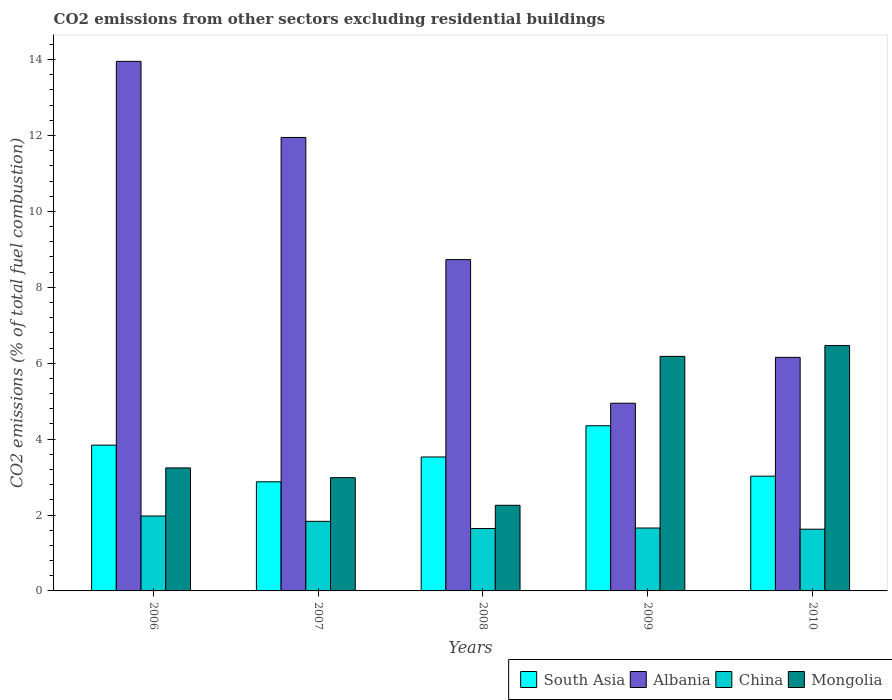How many different coloured bars are there?
Your answer should be very brief. 4. How many groups of bars are there?
Keep it short and to the point. 5. Are the number of bars per tick equal to the number of legend labels?
Ensure brevity in your answer.  Yes. How many bars are there on the 4th tick from the left?
Offer a very short reply. 4. What is the label of the 5th group of bars from the left?
Offer a terse response. 2010. In how many cases, is the number of bars for a given year not equal to the number of legend labels?
Offer a terse response. 0. What is the total CO2 emitted in Mongolia in 2007?
Give a very brief answer. 2.98. Across all years, what is the maximum total CO2 emitted in Albania?
Your answer should be compact. 13.95. Across all years, what is the minimum total CO2 emitted in China?
Your answer should be compact. 1.63. In which year was the total CO2 emitted in Albania maximum?
Provide a short and direct response. 2006. What is the total total CO2 emitted in Albania in the graph?
Provide a succinct answer. 45.73. What is the difference between the total CO2 emitted in South Asia in 2007 and that in 2010?
Your answer should be compact. -0.15. What is the difference between the total CO2 emitted in China in 2007 and the total CO2 emitted in Mongolia in 2010?
Provide a succinct answer. -4.63. What is the average total CO2 emitted in Mongolia per year?
Give a very brief answer. 4.23. In the year 2007, what is the difference between the total CO2 emitted in Albania and total CO2 emitted in South Asia?
Your answer should be compact. 9.07. What is the ratio of the total CO2 emitted in Mongolia in 2007 to that in 2009?
Offer a terse response. 0.48. Is the total CO2 emitted in Mongolia in 2008 less than that in 2009?
Offer a terse response. Yes. What is the difference between the highest and the second highest total CO2 emitted in South Asia?
Provide a succinct answer. 0.51. What is the difference between the highest and the lowest total CO2 emitted in South Asia?
Ensure brevity in your answer.  1.48. Is it the case that in every year, the sum of the total CO2 emitted in China and total CO2 emitted in Mongolia is greater than the sum of total CO2 emitted in Albania and total CO2 emitted in South Asia?
Keep it short and to the point. No. What does the 4th bar from the left in 2006 represents?
Your response must be concise. Mongolia. Are all the bars in the graph horizontal?
Ensure brevity in your answer.  No. How many years are there in the graph?
Your answer should be very brief. 5. Are the values on the major ticks of Y-axis written in scientific E-notation?
Provide a short and direct response. No. What is the title of the graph?
Ensure brevity in your answer.  CO2 emissions from other sectors excluding residential buildings. What is the label or title of the Y-axis?
Provide a short and direct response. CO2 emissions (% of total fuel combustion). What is the CO2 emissions (% of total fuel combustion) in South Asia in 2006?
Provide a succinct answer. 3.84. What is the CO2 emissions (% of total fuel combustion) of Albania in 2006?
Your response must be concise. 13.95. What is the CO2 emissions (% of total fuel combustion) in China in 2006?
Your answer should be very brief. 1.97. What is the CO2 emissions (% of total fuel combustion) of Mongolia in 2006?
Provide a succinct answer. 3.24. What is the CO2 emissions (% of total fuel combustion) in South Asia in 2007?
Ensure brevity in your answer.  2.88. What is the CO2 emissions (% of total fuel combustion) of Albania in 2007?
Provide a short and direct response. 11.95. What is the CO2 emissions (% of total fuel combustion) of China in 2007?
Give a very brief answer. 1.83. What is the CO2 emissions (% of total fuel combustion) of Mongolia in 2007?
Give a very brief answer. 2.98. What is the CO2 emissions (% of total fuel combustion) of South Asia in 2008?
Ensure brevity in your answer.  3.53. What is the CO2 emissions (% of total fuel combustion) in Albania in 2008?
Provide a succinct answer. 8.73. What is the CO2 emissions (% of total fuel combustion) in China in 2008?
Ensure brevity in your answer.  1.64. What is the CO2 emissions (% of total fuel combustion) in Mongolia in 2008?
Provide a short and direct response. 2.26. What is the CO2 emissions (% of total fuel combustion) of South Asia in 2009?
Keep it short and to the point. 4.35. What is the CO2 emissions (% of total fuel combustion) of Albania in 2009?
Give a very brief answer. 4.95. What is the CO2 emissions (% of total fuel combustion) of China in 2009?
Make the answer very short. 1.66. What is the CO2 emissions (% of total fuel combustion) of Mongolia in 2009?
Provide a short and direct response. 6.18. What is the CO2 emissions (% of total fuel combustion) in South Asia in 2010?
Give a very brief answer. 3.02. What is the CO2 emissions (% of total fuel combustion) in Albania in 2010?
Give a very brief answer. 6.15. What is the CO2 emissions (% of total fuel combustion) of China in 2010?
Your answer should be very brief. 1.63. What is the CO2 emissions (% of total fuel combustion) in Mongolia in 2010?
Provide a succinct answer. 6.46. Across all years, what is the maximum CO2 emissions (% of total fuel combustion) in South Asia?
Your answer should be compact. 4.35. Across all years, what is the maximum CO2 emissions (% of total fuel combustion) in Albania?
Give a very brief answer. 13.95. Across all years, what is the maximum CO2 emissions (% of total fuel combustion) in China?
Give a very brief answer. 1.97. Across all years, what is the maximum CO2 emissions (% of total fuel combustion) of Mongolia?
Your answer should be compact. 6.46. Across all years, what is the minimum CO2 emissions (% of total fuel combustion) of South Asia?
Make the answer very short. 2.88. Across all years, what is the minimum CO2 emissions (% of total fuel combustion) in Albania?
Your answer should be compact. 4.95. Across all years, what is the minimum CO2 emissions (% of total fuel combustion) of China?
Your answer should be compact. 1.63. Across all years, what is the minimum CO2 emissions (% of total fuel combustion) of Mongolia?
Make the answer very short. 2.26. What is the total CO2 emissions (% of total fuel combustion) in South Asia in the graph?
Keep it short and to the point. 17.62. What is the total CO2 emissions (% of total fuel combustion) in Albania in the graph?
Ensure brevity in your answer.  45.73. What is the total CO2 emissions (% of total fuel combustion) of China in the graph?
Your answer should be very brief. 8.74. What is the total CO2 emissions (% of total fuel combustion) of Mongolia in the graph?
Offer a very short reply. 21.13. What is the difference between the CO2 emissions (% of total fuel combustion) of South Asia in 2006 and that in 2007?
Your response must be concise. 0.97. What is the difference between the CO2 emissions (% of total fuel combustion) of Albania in 2006 and that in 2007?
Ensure brevity in your answer.  2.01. What is the difference between the CO2 emissions (% of total fuel combustion) in China in 2006 and that in 2007?
Provide a succinct answer. 0.14. What is the difference between the CO2 emissions (% of total fuel combustion) in Mongolia in 2006 and that in 2007?
Provide a succinct answer. 0.26. What is the difference between the CO2 emissions (% of total fuel combustion) in South Asia in 2006 and that in 2008?
Your response must be concise. 0.31. What is the difference between the CO2 emissions (% of total fuel combustion) of Albania in 2006 and that in 2008?
Your answer should be very brief. 5.22. What is the difference between the CO2 emissions (% of total fuel combustion) of China in 2006 and that in 2008?
Provide a succinct answer. 0.33. What is the difference between the CO2 emissions (% of total fuel combustion) in Mongolia in 2006 and that in 2008?
Provide a succinct answer. 0.98. What is the difference between the CO2 emissions (% of total fuel combustion) in South Asia in 2006 and that in 2009?
Offer a very short reply. -0.51. What is the difference between the CO2 emissions (% of total fuel combustion) in Albania in 2006 and that in 2009?
Your response must be concise. 9.01. What is the difference between the CO2 emissions (% of total fuel combustion) of China in 2006 and that in 2009?
Make the answer very short. 0.32. What is the difference between the CO2 emissions (% of total fuel combustion) of Mongolia in 2006 and that in 2009?
Keep it short and to the point. -2.94. What is the difference between the CO2 emissions (% of total fuel combustion) in South Asia in 2006 and that in 2010?
Your response must be concise. 0.82. What is the difference between the CO2 emissions (% of total fuel combustion) in Albania in 2006 and that in 2010?
Provide a short and direct response. 7.8. What is the difference between the CO2 emissions (% of total fuel combustion) in China in 2006 and that in 2010?
Make the answer very short. 0.35. What is the difference between the CO2 emissions (% of total fuel combustion) of Mongolia in 2006 and that in 2010?
Provide a succinct answer. -3.22. What is the difference between the CO2 emissions (% of total fuel combustion) in South Asia in 2007 and that in 2008?
Offer a terse response. -0.65. What is the difference between the CO2 emissions (% of total fuel combustion) in Albania in 2007 and that in 2008?
Offer a terse response. 3.22. What is the difference between the CO2 emissions (% of total fuel combustion) of China in 2007 and that in 2008?
Provide a succinct answer. 0.19. What is the difference between the CO2 emissions (% of total fuel combustion) of Mongolia in 2007 and that in 2008?
Offer a very short reply. 0.73. What is the difference between the CO2 emissions (% of total fuel combustion) in South Asia in 2007 and that in 2009?
Keep it short and to the point. -1.48. What is the difference between the CO2 emissions (% of total fuel combustion) of Albania in 2007 and that in 2009?
Offer a very short reply. 7. What is the difference between the CO2 emissions (% of total fuel combustion) in China in 2007 and that in 2009?
Your answer should be very brief. 0.18. What is the difference between the CO2 emissions (% of total fuel combustion) in Mongolia in 2007 and that in 2009?
Offer a very short reply. -3.2. What is the difference between the CO2 emissions (% of total fuel combustion) of South Asia in 2007 and that in 2010?
Give a very brief answer. -0.15. What is the difference between the CO2 emissions (% of total fuel combustion) in Albania in 2007 and that in 2010?
Provide a succinct answer. 5.79. What is the difference between the CO2 emissions (% of total fuel combustion) of China in 2007 and that in 2010?
Provide a succinct answer. 0.21. What is the difference between the CO2 emissions (% of total fuel combustion) in Mongolia in 2007 and that in 2010?
Make the answer very short. -3.48. What is the difference between the CO2 emissions (% of total fuel combustion) of South Asia in 2008 and that in 2009?
Ensure brevity in your answer.  -0.82. What is the difference between the CO2 emissions (% of total fuel combustion) in Albania in 2008 and that in 2009?
Provide a succinct answer. 3.79. What is the difference between the CO2 emissions (% of total fuel combustion) in China in 2008 and that in 2009?
Provide a short and direct response. -0.01. What is the difference between the CO2 emissions (% of total fuel combustion) of Mongolia in 2008 and that in 2009?
Make the answer very short. -3.92. What is the difference between the CO2 emissions (% of total fuel combustion) in South Asia in 2008 and that in 2010?
Offer a terse response. 0.51. What is the difference between the CO2 emissions (% of total fuel combustion) of Albania in 2008 and that in 2010?
Make the answer very short. 2.58. What is the difference between the CO2 emissions (% of total fuel combustion) of China in 2008 and that in 2010?
Provide a succinct answer. 0.02. What is the difference between the CO2 emissions (% of total fuel combustion) in Mongolia in 2008 and that in 2010?
Provide a short and direct response. -4.21. What is the difference between the CO2 emissions (% of total fuel combustion) of South Asia in 2009 and that in 2010?
Offer a terse response. 1.33. What is the difference between the CO2 emissions (% of total fuel combustion) in Albania in 2009 and that in 2010?
Provide a succinct answer. -1.21. What is the difference between the CO2 emissions (% of total fuel combustion) of China in 2009 and that in 2010?
Make the answer very short. 0.03. What is the difference between the CO2 emissions (% of total fuel combustion) of Mongolia in 2009 and that in 2010?
Your answer should be compact. -0.28. What is the difference between the CO2 emissions (% of total fuel combustion) of South Asia in 2006 and the CO2 emissions (% of total fuel combustion) of Albania in 2007?
Provide a short and direct response. -8.11. What is the difference between the CO2 emissions (% of total fuel combustion) of South Asia in 2006 and the CO2 emissions (% of total fuel combustion) of China in 2007?
Give a very brief answer. 2.01. What is the difference between the CO2 emissions (% of total fuel combustion) in South Asia in 2006 and the CO2 emissions (% of total fuel combustion) in Mongolia in 2007?
Give a very brief answer. 0.86. What is the difference between the CO2 emissions (% of total fuel combustion) of Albania in 2006 and the CO2 emissions (% of total fuel combustion) of China in 2007?
Your answer should be very brief. 12.12. What is the difference between the CO2 emissions (% of total fuel combustion) in Albania in 2006 and the CO2 emissions (% of total fuel combustion) in Mongolia in 2007?
Your answer should be compact. 10.97. What is the difference between the CO2 emissions (% of total fuel combustion) of China in 2006 and the CO2 emissions (% of total fuel combustion) of Mongolia in 2007?
Your answer should be very brief. -1.01. What is the difference between the CO2 emissions (% of total fuel combustion) in South Asia in 2006 and the CO2 emissions (% of total fuel combustion) in Albania in 2008?
Keep it short and to the point. -4.89. What is the difference between the CO2 emissions (% of total fuel combustion) of South Asia in 2006 and the CO2 emissions (% of total fuel combustion) of China in 2008?
Ensure brevity in your answer.  2.2. What is the difference between the CO2 emissions (% of total fuel combustion) in South Asia in 2006 and the CO2 emissions (% of total fuel combustion) in Mongolia in 2008?
Provide a succinct answer. 1.58. What is the difference between the CO2 emissions (% of total fuel combustion) of Albania in 2006 and the CO2 emissions (% of total fuel combustion) of China in 2008?
Give a very brief answer. 12.31. What is the difference between the CO2 emissions (% of total fuel combustion) of Albania in 2006 and the CO2 emissions (% of total fuel combustion) of Mongolia in 2008?
Offer a terse response. 11.7. What is the difference between the CO2 emissions (% of total fuel combustion) in China in 2006 and the CO2 emissions (% of total fuel combustion) in Mongolia in 2008?
Ensure brevity in your answer.  -0.28. What is the difference between the CO2 emissions (% of total fuel combustion) in South Asia in 2006 and the CO2 emissions (% of total fuel combustion) in Albania in 2009?
Keep it short and to the point. -1.1. What is the difference between the CO2 emissions (% of total fuel combustion) of South Asia in 2006 and the CO2 emissions (% of total fuel combustion) of China in 2009?
Make the answer very short. 2.18. What is the difference between the CO2 emissions (% of total fuel combustion) of South Asia in 2006 and the CO2 emissions (% of total fuel combustion) of Mongolia in 2009?
Your answer should be very brief. -2.34. What is the difference between the CO2 emissions (% of total fuel combustion) of Albania in 2006 and the CO2 emissions (% of total fuel combustion) of China in 2009?
Give a very brief answer. 12.3. What is the difference between the CO2 emissions (% of total fuel combustion) of Albania in 2006 and the CO2 emissions (% of total fuel combustion) of Mongolia in 2009?
Your answer should be compact. 7.77. What is the difference between the CO2 emissions (% of total fuel combustion) of China in 2006 and the CO2 emissions (% of total fuel combustion) of Mongolia in 2009?
Give a very brief answer. -4.21. What is the difference between the CO2 emissions (% of total fuel combustion) of South Asia in 2006 and the CO2 emissions (% of total fuel combustion) of Albania in 2010?
Offer a terse response. -2.31. What is the difference between the CO2 emissions (% of total fuel combustion) of South Asia in 2006 and the CO2 emissions (% of total fuel combustion) of China in 2010?
Provide a short and direct response. 2.21. What is the difference between the CO2 emissions (% of total fuel combustion) in South Asia in 2006 and the CO2 emissions (% of total fuel combustion) in Mongolia in 2010?
Offer a very short reply. -2.62. What is the difference between the CO2 emissions (% of total fuel combustion) of Albania in 2006 and the CO2 emissions (% of total fuel combustion) of China in 2010?
Provide a short and direct response. 12.33. What is the difference between the CO2 emissions (% of total fuel combustion) in Albania in 2006 and the CO2 emissions (% of total fuel combustion) in Mongolia in 2010?
Ensure brevity in your answer.  7.49. What is the difference between the CO2 emissions (% of total fuel combustion) in China in 2006 and the CO2 emissions (% of total fuel combustion) in Mongolia in 2010?
Keep it short and to the point. -4.49. What is the difference between the CO2 emissions (% of total fuel combustion) in South Asia in 2007 and the CO2 emissions (% of total fuel combustion) in Albania in 2008?
Make the answer very short. -5.85. What is the difference between the CO2 emissions (% of total fuel combustion) of South Asia in 2007 and the CO2 emissions (% of total fuel combustion) of China in 2008?
Offer a terse response. 1.23. What is the difference between the CO2 emissions (% of total fuel combustion) in South Asia in 2007 and the CO2 emissions (% of total fuel combustion) in Mongolia in 2008?
Your answer should be compact. 0.62. What is the difference between the CO2 emissions (% of total fuel combustion) of Albania in 2007 and the CO2 emissions (% of total fuel combustion) of China in 2008?
Ensure brevity in your answer.  10.3. What is the difference between the CO2 emissions (% of total fuel combustion) in Albania in 2007 and the CO2 emissions (% of total fuel combustion) in Mongolia in 2008?
Your response must be concise. 9.69. What is the difference between the CO2 emissions (% of total fuel combustion) of China in 2007 and the CO2 emissions (% of total fuel combustion) of Mongolia in 2008?
Make the answer very short. -0.42. What is the difference between the CO2 emissions (% of total fuel combustion) of South Asia in 2007 and the CO2 emissions (% of total fuel combustion) of Albania in 2009?
Offer a very short reply. -2.07. What is the difference between the CO2 emissions (% of total fuel combustion) in South Asia in 2007 and the CO2 emissions (% of total fuel combustion) in China in 2009?
Keep it short and to the point. 1.22. What is the difference between the CO2 emissions (% of total fuel combustion) in South Asia in 2007 and the CO2 emissions (% of total fuel combustion) in Mongolia in 2009?
Ensure brevity in your answer.  -3.3. What is the difference between the CO2 emissions (% of total fuel combustion) in Albania in 2007 and the CO2 emissions (% of total fuel combustion) in China in 2009?
Your answer should be very brief. 10.29. What is the difference between the CO2 emissions (% of total fuel combustion) of Albania in 2007 and the CO2 emissions (% of total fuel combustion) of Mongolia in 2009?
Keep it short and to the point. 5.77. What is the difference between the CO2 emissions (% of total fuel combustion) of China in 2007 and the CO2 emissions (% of total fuel combustion) of Mongolia in 2009?
Provide a short and direct response. -4.35. What is the difference between the CO2 emissions (% of total fuel combustion) of South Asia in 2007 and the CO2 emissions (% of total fuel combustion) of Albania in 2010?
Your response must be concise. -3.28. What is the difference between the CO2 emissions (% of total fuel combustion) in South Asia in 2007 and the CO2 emissions (% of total fuel combustion) in China in 2010?
Keep it short and to the point. 1.25. What is the difference between the CO2 emissions (% of total fuel combustion) of South Asia in 2007 and the CO2 emissions (% of total fuel combustion) of Mongolia in 2010?
Give a very brief answer. -3.59. What is the difference between the CO2 emissions (% of total fuel combustion) of Albania in 2007 and the CO2 emissions (% of total fuel combustion) of China in 2010?
Provide a short and direct response. 10.32. What is the difference between the CO2 emissions (% of total fuel combustion) in Albania in 2007 and the CO2 emissions (% of total fuel combustion) in Mongolia in 2010?
Ensure brevity in your answer.  5.48. What is the difference between the CO2 emissions (% of total fuel combustion) of China in 2007 and the CO2 emissions (% of total fuel combustion) of Mongolia in 2010?
Keep it short and to the point. -4.63. What is the difference between the CO2 emissions (% of total fuel combustion) of South Asia in 2008 and the CO2 emissions (% of total fuel combustion) of Albania in 2009?
Provide a short and direct response. -1.42. What is the difference between the CO2 emissions (% of total fuel combustion) in South Asia in 2008 and the CO2 emissions (% of total fuel combustion) in China in 2009?
Your response must be concise. 1.87. What is the difference between the CO2 emissions (% of total fuel combustion) of South Asia in 2008 and the CO2 emissions (% of total fuel combustion) of Mongolia in 2009?
Offer a very short reply. -2.65. What is the difference between the CO2 emissions (% of total fuel combustion) of Albania in 2008 and the CO2 emissions (% of total fuel combustion) of China in 2009?
Offer a terse response. 7.07. What is the difference between the CO2 emissions (% of total fuel combustion) of Albania in 2008 and the CO2 emissions (% of total fuel combustion) of Mongolia in 2009?
Give a very brief answer. 2.55. What is the difference between the CO2 emissions (% of total fuel combustion) of China in 2008 and the CO2 emissions (% of total fuel combustion) of Mongolia in 2009?
Give a very brief answer. -4.54. What is the difference between the CO2 emissions (% of total fuel combustion) of South Asia in 2008 and the CO2 emissions (% of total fuel combustion) of Albania in 2010?
Offer a very short reply. -2.62. What is the difference between the CO2 emissions (% of total fuel combustion) in South Asia in 2008 and the CO2 emissions (% of total fuel combustion) in China in 2010?
Your answer should be compact. 1.9. What is the difference between the CO2 emissions (% of total fuel combustion) of South Asia in 2008 and the CO2 emissions (% of total fuel combustion) of Mongolia in 2010?
Your answer should be very brief. -2.94. What is the difference between the CO2 emissions (% of total fuel combustion) in Albania in 2008 and the CO2 emissions (% of total fuel combustion) in China in 2010?
Keep it short and to the point. 7.1. What is the difference between the CO2 emissions (% of total fuel combustion) in Albania in 2008 and the CO2 emissions (% of total fuel combustion) in Mongolia in 2010?
Your answer should be compact. 2.27. What is the difference between the CO2 emissions (% of total fuel combustion) in China in 2008 and the CO2 emissions (% of total fuel combustion) in Mongolia in 2010?
Ensure brevity in your answer.  -4.82. What is the difference between the CO2 emissions (% of total fuel combustion) in South Asia in 2009 and the CO2 emissions (% of total fuel combustion) in Albania in 2010?
Make the answer very short. -1.8. What is the difference between the CO2 emissions (% of total fuel combustion) of South Asia in 2009 and the CO2 emissions (% of total fuel combustion) of China in 2010?
Your answer should be very brief. 2.73. What is the difference between the CO2 emissions (% of total fuel combustion) of South Asia in 2009 and the CO2 emissions (% of total fuel combustion) of Mongolia in 2010?
Your answer should be compact. -2.11. What is the difference between the CO2 emissions (% of total fuel combustion) of Albania in 2009 and the CO2 emissions (% of total fuel combustion) of China in 2010?
Ensure brevity in your answer.  3.32. What is the difference between the CO2 emissions (% of total fuel combustion) in Albania in 2009 and the CO2 emissions (% of total fuel combustion) in Mongolia in 2010?
Offer a terse response. -1.52. What is the difference between the CO2 emissions (% of total fuel combustion) of China in 2009 and the CO2 emissions (% of total fuel combustion) of Mongolia in 2010?
Make the answer very short. -4.81. What is the average CO2 emissions (% of total fuel combustion) of South Asia per year?
Offer a very short reply. 3.52. What is the average CO2 emissions (% of total fuel combustion) of Albania per year?
Make the answer very short. 9.15. What is the average CO2 emissions (% of total fuel combustion) in China per year?
Offer a terse response. 1.75. What is the average CO2 emissions (% of total fuel combustion) of Mongolia per year?
Your answer should be compact. 4.23. In the year 2006, what is the difference between the CO2 emissions (% of total fuel combustion) in South Asia and CO2 emissions (% of total fuel combustion) in Albania?
Ensure brevity in your answer.  -10.11. In the year 2006, what is the difference between the CO2 emissions (% of total fuel combustion) in South Asia and CO2 emissions (% of total fuel combustion) in China?
Your answer should be very brief. 1.87. In the year 2006, what is the difference between the CO2 emissions (% of total fuel combustion) in South Asia and CO2 emissions (% of total fuel combustion) in Mongolia?
Your answer should be compact. 0.6. In the year 2006, what is the difference between the CO2 emissions (% of total fuel combustion) of Albania and CO2 emissions (% of total fuel combustion) of China?
Offer a terse response. 11.98. In the year 2006, what is the difference between the CO2 emissions (% of total fuel combustion) of Albania and CO2 emissions (% of total fuel combustion) of Mongolia?
Provide a short and direct response. 10.71. In the year 2006, what is the difference between the CO2 emissions (% of total fuel combustion) of China and CO2 emissions (% of total fuel combustion) of Mongolia?
Keep it short and to the point. -1.27. In the year 2007, what is the difference between the CO2 emissions (% of total fuel combustion) in South Asia and CO2 emissions (% of total fuel combustion) in Albania?
Provide a short and direct response. -9.07. In the year 2007, what is the difference between the CO2 emissions (% of total fuel combustion) in South Asia and CO2 emissions (% of total fuel combustion) in China?
Offer a terse response. 1.04. In the year 2007, what is the difference between the CO2 emissions (% of total fuel combustion) in South Asia and CO2 emissions (% of total fuel combustion) in Mongolia?
Ensure brevity in your answer.  -0.11. In the year 2007, what is the difference between the CO2 emissions (% of total fuel combustion) of Albania and CO2 emissions (% of total fuel combustion) of China?
Ensure brevity in your answer.  10.11. In the year 2007, what is the difference between the CO2 emissions (% of total fuel combustion) in Albania and CO2 emissions (% of total fuel combustion) in Mongolia?
Give a very brief answer. 8.96. In the year 2007, what is the difference between the CO2 emissions (% of total fuel combustion) of China and CO2 emissions (% of total fuel combustion) of Mongolia?
Offer a very short reply. -1.15. In the year 2008, what is the difference between the CO2 emissions (% of total fuel combustion) in South Asia and CO2 emissions (% of total fuel combustion) in Albania?
Your answer should be very brief. -5.2. In the year 2008, what is the difference between the CO2 emissions (% of total fuel combustion) of South Asia and CO2 emissions (% of total fuel combustion) of China?
Offer a very short reply. 1.89. In the year 2008, what is the difference between the CO2 emissions (% of total fuel combustion) in South Asia and CO2 emissions (% of total fuel combustion) in Mongolia?
Offer a very short reply. 1.27. In the year 2008, what is the difference between the CO2 emissions (% of total fuel combustion) in Albania and CO2 emissions (% of total fuel combustion) in China?
Make the answer very short. 7.09. In the year 2008, what is the difference between the CO2 emissions (% of total fuel combustion) in Albania and CO2 emissions (% of total fuel combustion) in Mongolia?
Provide a short and direct response. 6.47. In the year 2008, what is the difference between the CO2 emissions (% of total fuel combustion) of China and CO2 emissions (% of total fuel combustion) of Mongolia?
Your answer should be compact. -0.61. In the year 2009, what is the difference between the CO2 emissions (% of total fuel combustion) in South Asia and CO2 emissions (% of total fuel combustion) in Albania?
Give a very brief answer. -0.59. In the year 2009, what is the difference between the CO2 emissions (% of total fuel combustion) of South Asia and CO2 emissions (% of total fuel combustion) of China?
Keep it short and to the point. 2.69. In the year 2009, what is the difference between the CO2 emissions (% of total fuel combustion) in South Asia and CO2 emissions (% of total fuel combustion) in Mongolia?
Provide a succinct answer. -1.83. In the year 2009, what is the difference between the CO2 emissions (% of total fuel combustion) of Albania and CO2 emissions (% of total fuel combustion) of China?
Offer a terse response. 3.29. In the year 2009, what is the difference between the CO2 emissions (% of total fuel combustion) of Albania and CO2 emissions (% of total fuel combustion) of Mongolia?
Provide a succinct answer. -1.24. In the year 2009, what is the difference between the CO2 emissions (% of total fuel combustion) of China and CO2 emissions (% of total fuel combustion) of Mongolia?
Provide a succinct answer. -4.52. In the year 2010, what is the difference between the CO2 emissions (% of total fuel combustion) of South Asia and CO2 emissions (% of total fuel combustion) of Albania?
Your response must be concise. -3.13. In the year 2010, what is the difference between the CO2 emissions (% of total fuel combustion) in South Asia and CO2 emissions (% of total fuel combustion) in China?
Ensure brevity in your answer.  1.4. In the year 2010, what is the difference between the CO2 emissions (% of total fuel combustion) of South Asia and CO2 emissions (% of total fuel combustion) of Mongolia?
Keep it short and to the point. -3.44. In the year 2010, what is the difference between the CO2 emissions (% of total fuel combustion) in Albania and CO2 emissions (% of total fuel combustion) in China?
Your answer should be compact. 4.53. In the year 2010, what is the difference between the CO2 emissions (% of total fuel combustion) of Albania and CO2 emissions (% of total fuel combustion) of Mongolia?
Provide a short and direct response. -0.31. In the year 2010, what is the difference between the CO2 emissions (% of total fuel combustion) of China and CO2 emissions (% of total fuel combustion) of Mongolia?
Keep it short and to the point. -4.84. What is the ratio of the CO2 emissions (% of total fuel combustion) in South Asia in 2006 to that in 2007?
Your answer should be compact. 1.34. What is the ratio of the CO2 emissions (% of total fuel combustion) of Albania in 2006 to that in 2007?
Your answer should be very brief. 1.17. What is the ratio of the CO2 emissions (% of total fuel combustion) in China in 2006 to that in 2007?
Give a very brief answer. 1.08. What is the ratio of the CO2 emissions (% of total fuel combustion) of Mongolia in 2006 to that in 2007?
Offer a terse response. 1.09. What is the ratio of the CO2 emissions (% of total fuel combustion) in South Asia in 2006 to that in 2008?
Your answer should be compact. 1.09. What is the ratio of the CO2 emissions (% of total fuel combustion) of Albania in 2006 to that in 2008?
Your response must be concise. 1.6. What is the ratio of the CO2 emissions (% of total fuel combustion) in China in 2006 to that in 2008?
Your response must be concise. 1.2. What is the ratio of the CO2 emissions (% of total fuel combustion) of Mongolia in 2006 to that in 2008?
Offer a terse response. 1.44. What is the ratio of the CO2 emissions (% of total fuel combustion) of South Asia in 2006 to that in 2009?
Offer a very short reply. 0.88. What is the ratio of the CO2 emissions (% of total fuel combustion) of Albania in 2006 to that in 2009?
Ensure brevity in your answer.  2.82. What is the ratio of the CO2 emissions (% of total fuel combustion) of China in 2006 to that in 2009?
Provide a succinct answer. 1.19. What is the ratio of the CO2 emissions (% of total fuel combustion) in Mongolia in 2006 to that in 2009?
Your response must be concise. 0.52. What is the ratio of the CO2 emissions (% of total fuel combustion) in South Asia in 2006 to that in 2010?
Provide a succinct answer. 1.27. What is the ratio of the CO2 emissions (% of total fuel combustion) of Albania in 2006 to that in 2010?
Your answer should be compact. 2.27. What is the ratio of the CO2 emissions (% of total fuel combustion) of China in 2006 to that in 2010?
Your answer should be compact. 1.21. What is the ratio of the CO2 emissions (% of total fuel combustion) in Mongolia in 2006 to that in 2010?
Your response must be concise. 0.5. What is the ratio of the CO2 emissions (% of total fuel combustion) in South Asia in 2007 to that in 2008?
Offer a very short reply. 0.81. What is the ratio of the CO2 emissions (% of total fuel combustion) of Albania in 2007 to that in 2008?
Offer a terse response. 1.37. What is the ratio of the CO2 emissions (% of total fuel combustion) of China in 2007 to that in 2008?
Your response must be concise. 1.12. What is the ratio of the CO2 emissions (% of total fuel combustion) of Mongolia in 2007 to that in 2008?
Offer a very short reply. 1.32. What is the ratio of the CO2 emissions (% of total fuel combustion) of South Asia in 2007 to that in 2009?
Keep it short and to the point. 0.66. What is the ratio of the CO2 emissions (% of total fuel combustion) of Albania in 2007 to that in 2009?
Make the answer very short. 2.42. What is the ratio of the CO2 emissions (% of total fuel combustion) in China in 2007 to that in 2009?
Ensure brevity in your answer.  1.11. What is the ratio of the CO2 emissions (% of total fuel combustion) in Mongolia in 2007 to that in 2009?
Give a very brief answer. 0.48. What is the ratio of the CO2 emissions (% of total fuel combustion) in South Asia in 2007 to that in 2010?
Keep it short and to the point. 0.95. What is the ratio of the CO2 emissions (% of total fuel combustion) of Albania in 2007 to that in 2010?
Provide a short and direct response. 1.94. What is the ratio of the CO2 emissions (% of total fuel combustion) in China in 2007 to that in 2010?
Give a very brief answer. 1.13. What is the ratio of the CO2 emissions (% of total fuel combustion) in Mongolia in 2007 to that in 2010?
Your answer should be very brief. 0.46. What is the ratio of the CO2 emissions (% of total fuel combustion) in South Asia in 2008 to that in 2009?
Your answer should be very brief. 0.81. What is the ratio of the CO2 emissions (% of total fuel combustion) in Albania in 2008 to that in 2009?
Give a very brief answer. 1.77. What is the ratio of the CO2 emissions (% of total fuel combustion) of China in 2008 to that in 2009?
Your response must be concise. 0.99. What is the ratio of the CO2 emissions (% of total fuel combustion) in Mongolia in 2008 to that in 2009?
Offer a terse response. 0.37. What is the ratio of the CO2 emissions (% of total fuel combustion) in South Asia in 2008 to that in 2010?
Your response must be concise. 1.17. What is the ratio of the CO2 emissions (% of total fuel combustion) in Albania in 2008 to that in 2010?
Make the answer very short. 1.42. What is the ratio of the CO2 emissions (% of total fuel combustion) of China in 2008 to that in 2010?
Provide a short and direct response. 1.01. What is the ratio of the CO2 emissions (% of total fuel combustion) of Mongolia in 2008 to that in 2010?
Offer a terse response. 0.35. What is the ratio of the CO2 emissions (% of total fuel combustion) in South Asia in 2009 to that in 2010?
Provide a succinct answer. 1.44. What is the ratio of the CO2 emissions (% of total fuel combustion) in Albania in 2009 to that in 2010?
Ensure brevity in your answer.  0.8. What is the ratio of the CO2 emissions (% of total fuel combustion) of China in 2009 to that in 2010?
Your answer should be compact. 1.02. What is the ratio of the CO2 emissions (% of total fuel combustion) in Mongolia in 2009 to that in 2010?
Provide a succinct answer. 0.96. What is the difference between the highest and the second highest CO2 emissions (% of total fuel combustion) in South Asia?
Your answer should be very brief. 0.51. What is the difference between the highest and the second highest CO2 emissions (% of total fuel combustion) in Albania?
Provide a short and direct response. 2.01. What is the difference between the highest and the second highest CO2 emissions (% of total fuel combustion) in China?
Provide a succinct answer. 0.14. What is the difference between the highest and the second highest CO2 emissions (% of total fuel combustion) of Mongolia?
Give a very brief answer. 0.28. What is the difference between the highest and the lowest CO2 emissions (% of total fuel combustion) of South Asia?
Offer a very short reply. 1.48. What is the difference between the highest and the lowest CO2 emissions (% of total fuel combustion) in Albania?
Offer a very short reply. 9.01. What is the difference between the highest and the lowest CO2 emissions (% of total fuel combustion) in China?
Keep it short and to the point. 0.35. What is the difference between the highest and the lowest CO2 emissions (% of total fuel combustion) in Mongolia?
Provide a succinct answer. 4.21. 